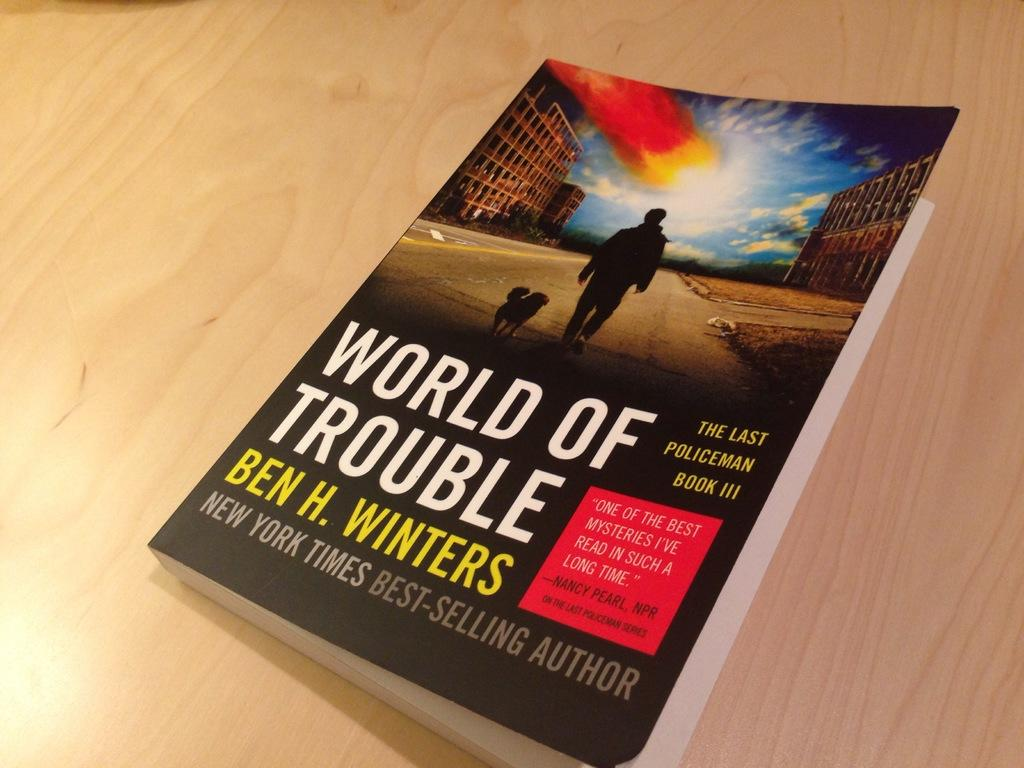Provide a one-sentence caption for the provided image. Book called the World of Trouble lays on a wooden table. 